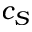<formula> <loc_0><loc_0><loc_500><loc_500>c _ { S }</formula> 